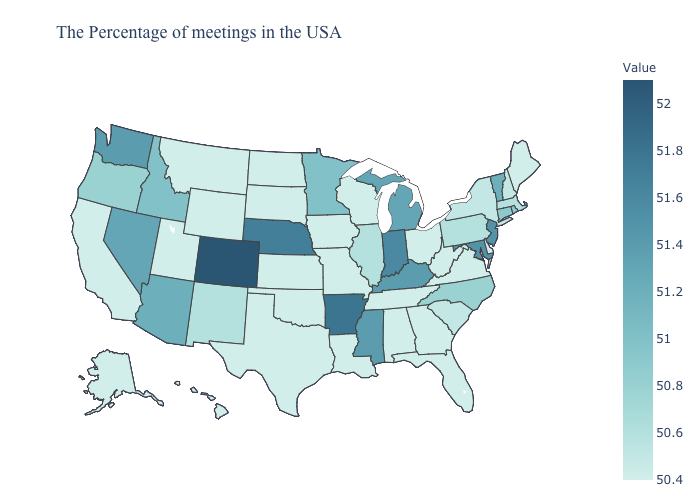Does Connecticut have the highest value in the Northeast?
Give a very brief answer. No. Among the states that border New Jersey , does Delaware have the highest value?
Concise answer only. No. Does Massachusetts have the highest value in the Northeast?
Write a very short answer. No. Which states have the highest value in the USA?
Write a very short answer. Colorado. Does Oregon have a lower value than Louisiana?
Short answer required. No. Does Iowa have the lowest value in the USA?
Short answer required. Yes. Does Rhode Island have the highest value in the Northeast?
Quick response, please. No. Does the map have missing data?
Write a very short answer. No. Does New Jersey have the highest value in the Northeast?
Concise answer only. Yes. Does Utah have a lower value than New Mexico?
Answer briefly. Yes. 